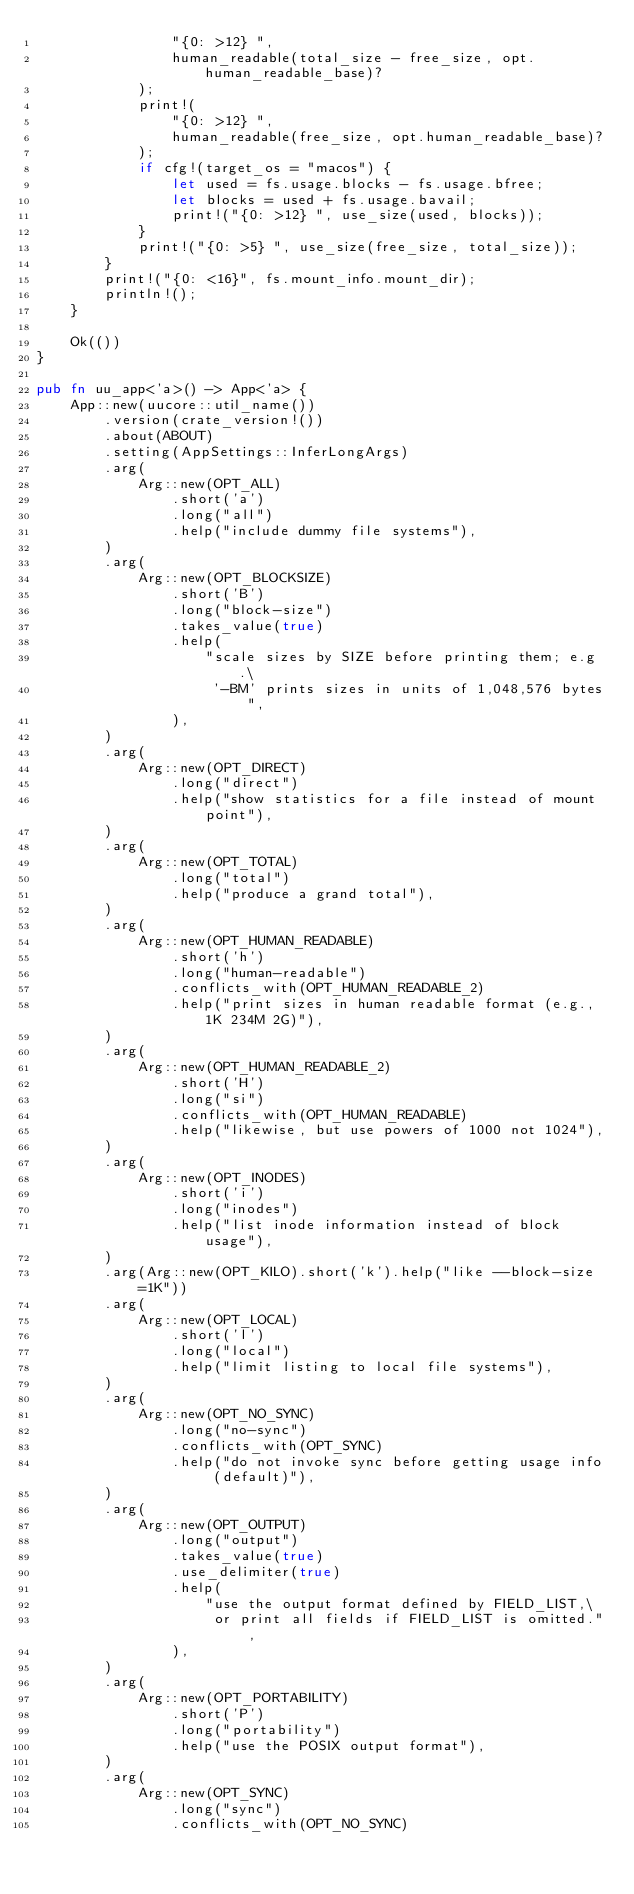<code> <loc_0><loc_0><loc_500><loc_500><_Rust_>                "{0: >12} ",
                human_readable(total_size - free_size, opt.human_readable_base)?
            );
            print!(
                "{0: >12} ",
                human_readable(free_size, opt.human_readable_base)?
            );
            if cfg!(target_os = "macos") {
                let used = fs.usage.blocks - fs.usage.bfree;
                let blocks = used + fs.usage.bavail;
                print!("{0: >12} ", use_size(used, blocks));
            }
            print!("{0: >5} ", use_size(free_size, total_size));
        }
        print!("{0: <16}", fs.mount_info.mount_dir);
        println!();
    }

    Ok(())
}

pub fn uu_app<'a>() -> App<'a> {
    App::new(uucore::util_name())
        .version(crate_version!())
        .about(ABOUT)
        .setting(AppSettings::InferLongArgs)
        .arg(
            Arg::new(OPT_ALL)
                .short('a')
                .long("all")
                .help("include dummy file systems"),
        )
        .arg(
            Arg::new(OPT_BLOCKSIZE)
                .short('B')
                .long("block-size")
                .takes_value(true)
                .help(
                    "scale sizes by SIZE before printing them; e.g.\
                     '-BM' prints sizes in units of 1,048,576 bytes",
                ),
        )
        .arg(
            Arg::new(OPT_DIRECT)
                .long("direct")
                .help("show statistics for a file instead of mount point"),
        )
        .arg(
            Arg::new(OPT_TOTAL)
                .long("total")
                .help("produce a grand total"),
        )
        .arg(
            Arg::new(OPT_HUMAN_READABLE)
                .short('h')
                .long("human-readable")
                .conflicts_with(OPT_HUMAN_READABLE_2)
                .help("print sizes in human readable format (e.g., 1K 234M 2G)"),
        )
        .arg(
            Arg::new(OPT_HUMAN_READABLE_2)
                .short('H')
                .long("si")
                .conflicts_with(OPT_HUMAN_READABLE)
                .help("likewise, but use powers of 1000 not 1024"),
        )
        .arg(
            Arg::new(OPT_INODES)
                .short('i')
                .long("inodes")
                .help("list inode information instead of block usage"),
        )
        .arg(Arg::new(OPT_KILO).short('k').help("like --block-size=1K"))
        .arg(
            Arg::new(OPT_LOCAL)
                .short('l')
                .long("local")
                .help("limit listing to local file systems"),
        )
        .arg(
            Arg::new(OPT_NO_SYNC)
                .long("no-sync")
                .conflicts_with(OPT_SYNC)
                .help("do not invoke sync before getting usage info (default)"),
        )
        .arg(
            Arg::new(OPT_OUTPUT)
                .long("output")
                .takes_value(true)
                .use_delimiter(true)
                .help(
                    "use the output format defined by FIELD_LIST,\
                     or print all fields if FIELD_LIST is omitted.",
                ),
        )
        .arg(
            Arg::new(OPT_PORTABILITY)
                .short('P')
                .long("portability")
                .help("use the POSIX output format"),
        )
        .arg(
            Arg::new(OPT_SYNC)
                .long("sync")
                .conflicts_with(OPT_NO_SYNC)</code> 